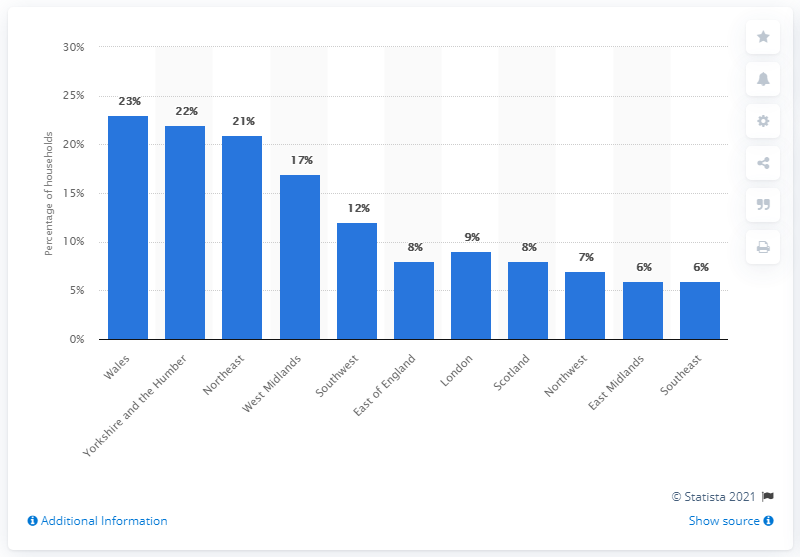List a handful of essential elements in this visual. In 2013, approximately 23% of households in Wales owned three or more cats. According to the data, the region with the highest proportion of households with three or more cats was Wales. 